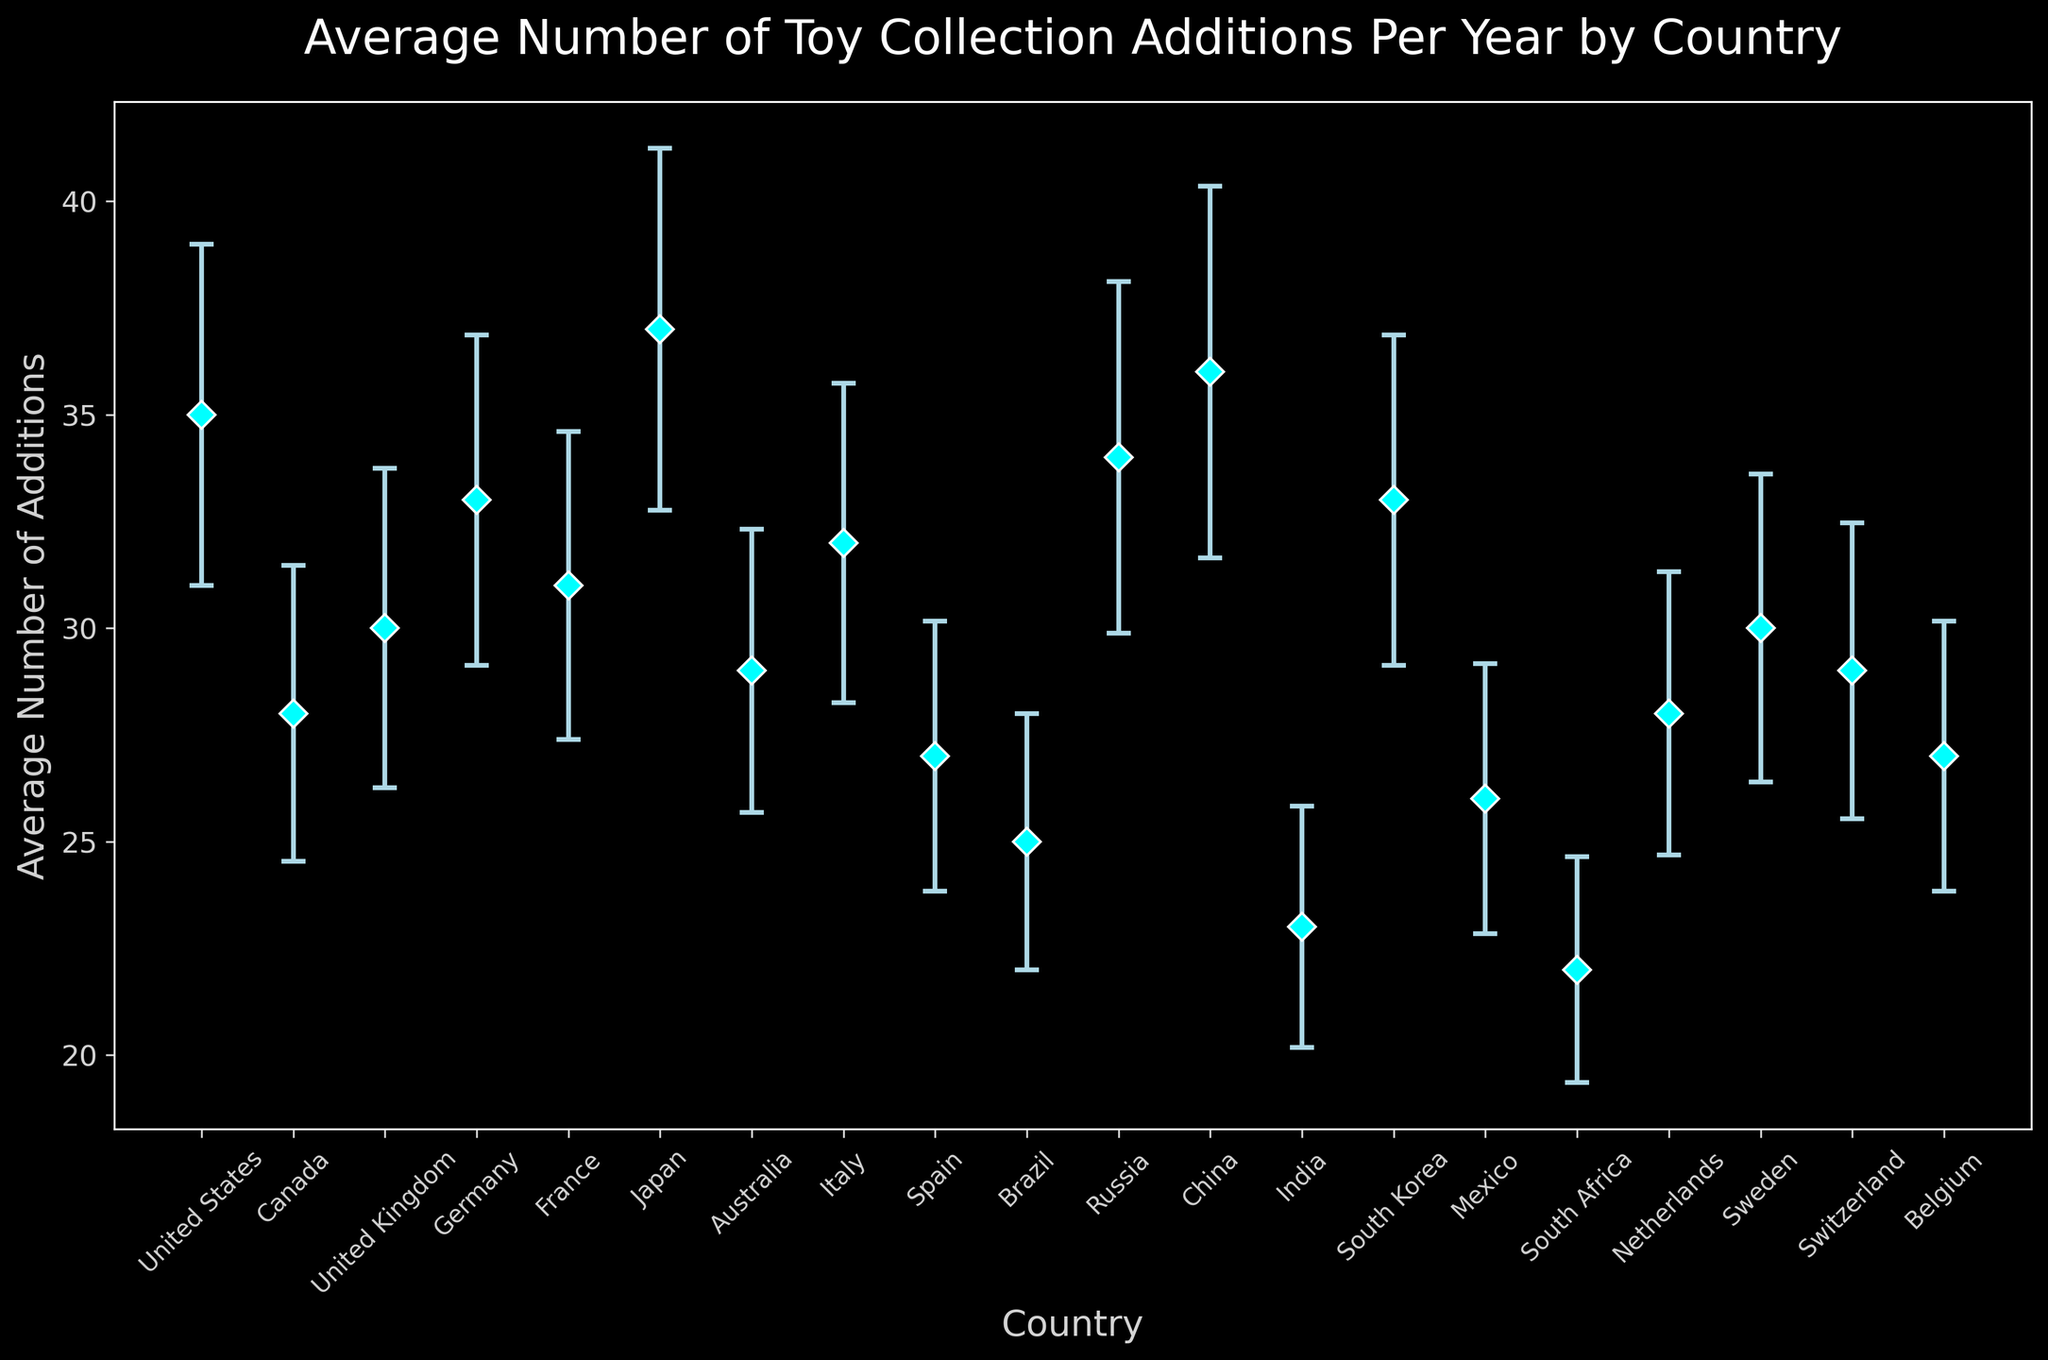What's the country with the highest average number of toy collection additions per year? The highest point on the chart represents the highest average number, which is Japan with 37 additions.
Answer: Japan Which country has the lowest variance in toy collection additions? The lowest variance corresponds to the smallest error bar, which belongs to South Africa with a variance of 7.
Answer: South Africa How does the United States compare to China in terms of the average number of toy collection additions? The plot shows that the United States has an average of 35 additions per year while China has 36 additions, so China has slightly more.
Answer: China has slightly more What is the difference in average toy collection additions per year between France and Germany? France has 31 and Germany has 33 average additions. The difference is 33 - 31 = 2 additions.
Answer: 2 additions What is the sum of the average toy collection additions per year for Canada and the United Kingdom? The averages for Canada and the UK are 28 and 30 respectively. Summing them gives 28 + 30 = 58.
Answer: 58 Which country has the longest error bar? The length of error bars represents the standard deviation. China has the longest error bar indicating the highest variance with an error corresponding to a variance of 19.
Answer: China Is there any country with the same average number of additions as Germany? South Korea also has an average of 33, the same as Germany.
Answer: South Korea What’s the combined average toy collection additions per year for all countries with more than 30 average additions? The countries are United States (35), Germany (33), France (31), Japan (37), Russia (34), China (36), and South Korea (33). Summing these gives 35 + 33 + 31 + 37 + 34 + 36 + 33 = 239.
Answer: 239 Are there any countries with equal variances? Yes, Canada and Switzerland both have a variance of 12. Additionally, Australia and the Netherlands have a variance of 11, and Belgium and Spain have a variance of 10.
Answer: Canada and Switzerland; Australia and Netherlands; Belgium and Spain What is the average variance across all countries? Sum all variances and divide by the number of countries. The variances sum is 233 across 20 countries, so the average variance is 233/20 = 11.65.
Answer: 11.65 